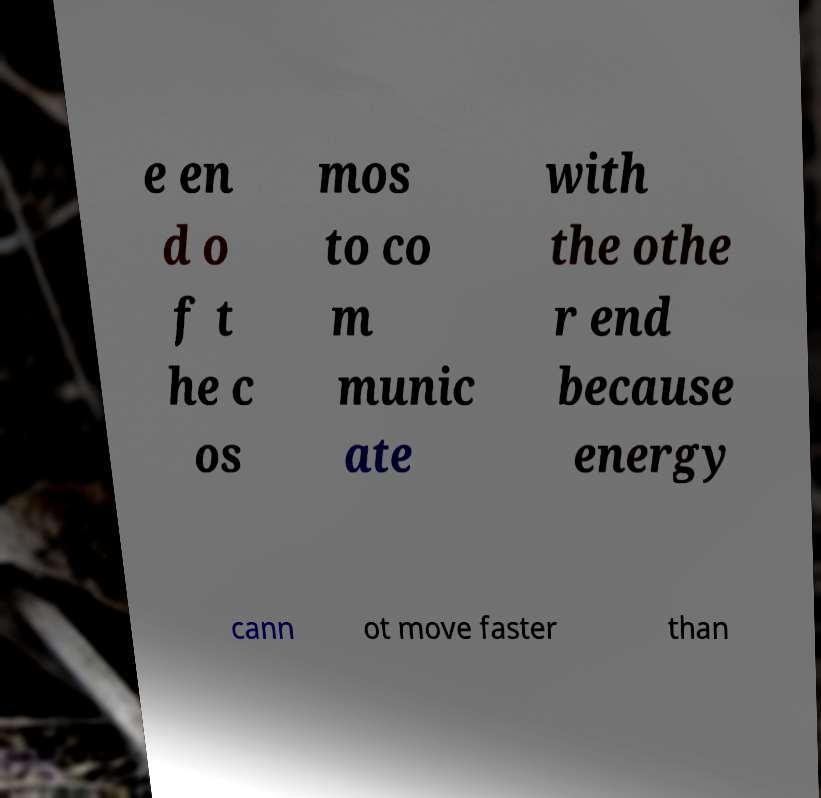Could you extract and type out the text from this image? e en d o f t he c os mos to co m munic ate with the othe r end because energy cann ot move faster than 